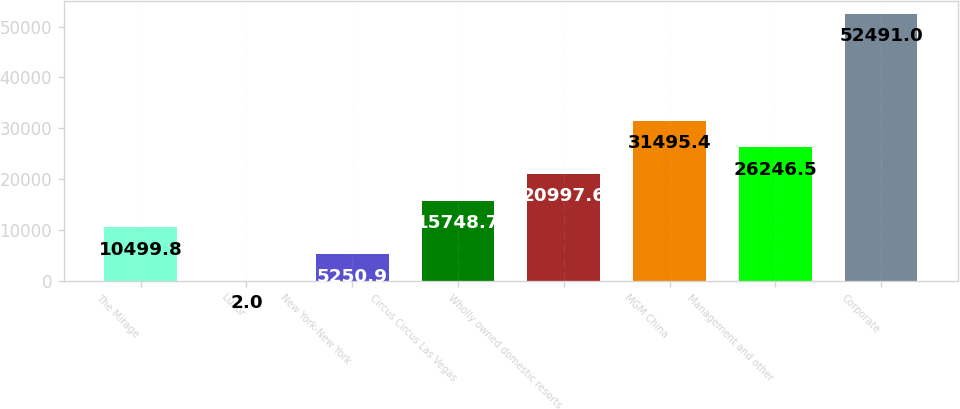Convert chart. <chart><loc_0><loc_0><loc_500><loc_500><bar_chart><fcel>The Mirage<fcel>Luxor<fcel>New York-New York<fcel>Circus Circus Las Vegas<fcel>Wholly owned domestic resorts<fcel>MGM China<fcel>Management and other<fcel>Corporate<nl><fcel>10499.8<fcel>2<fcel>5250.9<fcel>15748.7<fcel>20997.6<fcel>31495.4<fcel>26246.5<fcel>52491<nl></chart> 